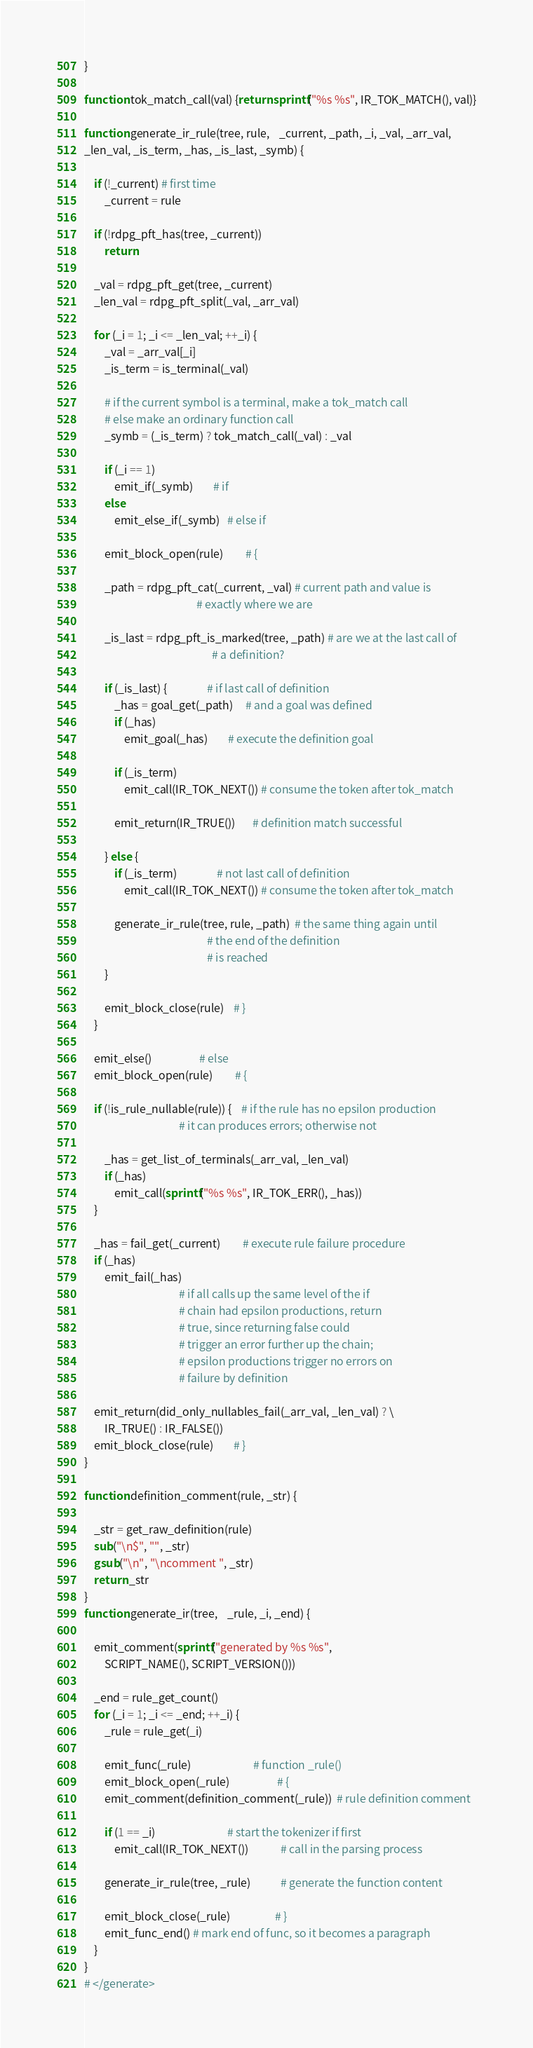Convert code to text. <code><loc_0><loc_0><loc_500><loc_500><_Awk_>}

function tok_match_call(val) {return sprintf("%s %s", IR_TOK_MATCH(), val)}

function generate_ir_rule(tree, rule,    _current, _path, _i, _val, _arr_val,
_len_val, _is_term, _has, _is_last, _symb) {
	
	if (!_current) # first time
		_current = rule
	
	if (!rdpg_pft_has(tree, _current))
		return
	
	_val = rdpg_pft_get(tree, _current)
	_len_val = rdpg_pft_split(_val, _arr_val)
	
	for (_i = 1; _i <= _len_val; ++_i) {
		_val = _arr_val[_i]
		_is_term = is_terminal(_val)
		
		# if the current symbol is a terminal, make a tok_match call
		# else make an ordinary function call
		_symb = (_is_term) ? tok_match_call(_val) : _val
		
		if (_i == 1)
			emit_if(_symb)        # if
		else 
			emit_else_if(_symb)   # else if
			
		emit_block_open(rule)         # {
		
		_path = rdpg_pft_cat(_current, _val) # current path and value is 
		                                     # exactly where we are
		
		_is_last = rdpg_pft_is_marked(tree, _path) # are we at the last call of
		                                           # a definition?
		
		if (_is_last) {                # if last call of definition
			_has = goal_get(_path)     # and a goal was defined
			if (_has)
				emit_goal(_has)        # execute the definition goal
		
			if (_is_term)
				emit_call(IR_TOK_NEXT()) # consume the token after tok_match

			emit_return(IR_TRUE())       # definition match successful
		
		} else {
			if (_is_term)                # not last call of definition
				emit_call(IR_TOK_NEXT()) # consume the token after tok_match
			
			generate_ir_rule(tree, rule, _path)  # the same thing again until
			                                     # the end of the definition
			                                     # is reached
		}
		
		emit_block_close(rule)    # }
	}

	emit_else()                   # else
	emit_block_open(rule)         # {
	
	if (!is_rule_nullable(rule)) {    # if the rule has no epsilon production
	                                  # it can produces errors; otherwise not
	                                  
		_has = get_list_of_terminals(_arr_val, _len_val)
		if (_has)
			emit_call(sprintf("%s %s", IR_TOK_ERR(), _has))
	}
	
	_has = fail_get(_current)         # execute rule failure procedure
	if (_has)
		emit_fail(_has)
	                                  # if all calls up the same level of the if
	                                  # chain had epsilon productions, return
	                                  # true, since returning false could
	                                  # trigger an error further up the chain;
	                                  # epsilon productions trigger no errors on
	                                  # failure by definition
	
	emit_return(did_only_nullables_fail(_arr_val, _len_val) ? \
		IR_TRUE() : IR_FALSE())
	emit_block_close(rule)        # }
}

function definition_comment(rule, _str) {

	_str = get_raw_definition(rule)
	sub("\n$", "", _str)
	gsub("\n", "\ncomment ", _str)
	return _str
}
function generate_ir(tree,    _rule, _i, _end) {

	emit_comment(sprintf("generated by %s %s",
		SCRIPT_NAME(), SCRIPT_VERSION()))

	_end = rule_get_count()
	for (_i = 1; _i <= _end; ++_i) {
		_rule = rule_get(_i)
			
		emit_func(_rule)                         # function _rule()
		emit_block_open(_rule)                   # {
		emit_comment(definition_comment(_rule))  # rule definition comment
		
		if (1 == _i)                             # start the tokenizer if first
			emit_call(IR_TOK_NEXT())             # call in the parsing process
		
		generate_ir_rule(tree, _rule)            # generate the function content
		
		emit_block_close(_rule)                  # }
		emit_func_end() # mark end of func, so it becomes a paragraph
	}
}
# </generate>
</code> 